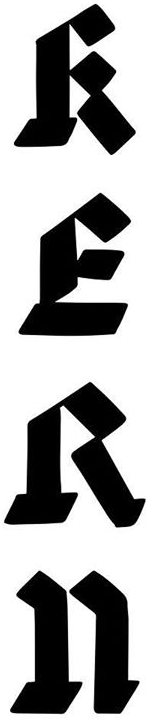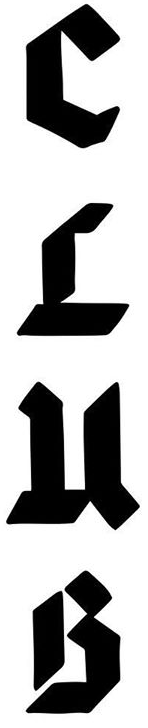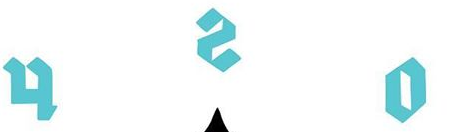What text is displayed in these images sequentially, separated by a semicolon? RERn; CLuB; osh 